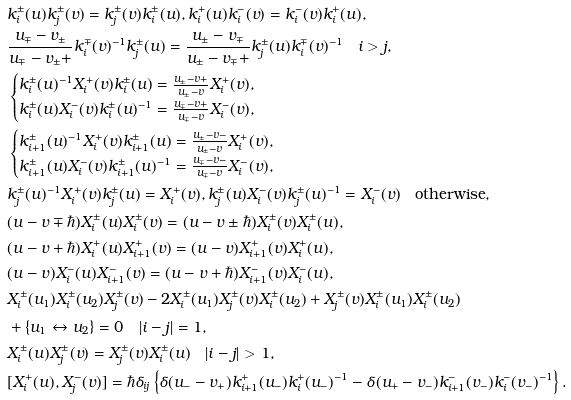Convert formula to latex. <formula><loc_0><loc_0><loc_500><loc_500>& k _ { i } ^ { \pm } ( u ) k _ { j } ^ { \pm } ( v ) = k _ { j } ^ { \pm } ( v ) k _ { i } ^ { \pm } ( u ) , k _ { i } ^ { + } ( u ) k _ { i } ^ { - } ( v ) = k _ { i } ^ { - } ( v ) k _ { i } ^ { + } ( u ) , \\ & \frac { u _ { \mp } - v _ { \pm } } { u _ { \mp } - v _ { \pm } + } k _ { i } ^ { \mp } ( v ) ^ { - 1 } k _ { j } ^ { \pm } ( u ) = \frac { u _ { \pm } - v _ { \mp } } { u _ { \pm } - v _ { \mp } + } k _ { j } ^ { \pm } ( u ) k _ { i } ^ { \mp } ( v ) ^ { - 1 } \quad i > j , \\ & \begin{cases} k _ { i } ^ { \pm } ( u ) ^ { - 1 } X _ { i } ^ { + } ( v ) k _ { i } ^ { \pm } ( u ) = \frac { u _ { \pm } - v + } { u _ { \pm } - v } X _ { i } ^ { + } ( v ) , & \\ k _ { i } ^ { \pm } ( u ) X _ { i } ^ { - } ( v ) k _ { i } ^ { \pm } ( u ) ^ { - 1 } = \frac { u _ { \mp } - v + } { u _ { \mp } - v } X _ { i } ^ { - } ( v ) , & \end{cases} \\ & \begin{cases} k _ { i + 1 } ^ { \pm } ( u ) ^ { - 1 } X _ { i } ^ { + } ( v ) k _ { i + 1 } ^ { \pm } ( u ) = \frac { u _ { \pm } - v - } { u _ { \pm } - v } X _ { i } ^ { + } ( v ) , & \\ k _ { i + 1 } ^ { \pm } ( u ) X _ { i } ^ { - } ( v ) k _ { i + 1 } ^ { \pm } ( u ) ^ { - 1 } = \frac { u _ { \mp } - v - } { u _ { \mp } - v } X _ { i } ^ { - } ( v ) , & \end{cases} \\ & k _ { j } ^ { \pm } ( u ) ^ { - 1 } X _ { i } ^ { + } ( v ) k _ { j } ^ { \pm } ( u ) = X _ { i } ^ { + } ( v ) , k _ { j } ^ { \pm } ( u ) X _ { i } ^ { - } ( v ) k _ { j } ^ { \pm } ( u ) ^ { - 1 } = X _ { i } ^ { - } ( v ) \quad \text {otherwise} , \\ & ( u - v \mp \hbar { ) } X _ { i } ^ { \pm } ( u ) X _ { i } ^ { \pm } ( v ) = ( u - v \pm \hbar { ) } X _ { i } ^ { \pm } ( v ) X _ { i } ^ { \pm } ( u ) , \\ & ( u - v + \hbar { ) } X _ { i } ^ { + } ( u ) X _ { i + 1 } ^ { + } ( v ) = ( u - v ) X _ { i + 1 } ^ { + } ( v ) X _ { i } ^ { + } ( u ) , \\ & ( u - v ) X _ { i } ^ { - } ( u ) X _ { i + 1 } ^ { - } ( v ) = ( u - v + \hbar { ) } X _ { i + 1 } ^ { - } ( v ) X _ { i } ^ { - } ( u ) , \\ & X _ { i } ^ { \pm } ( u _ { 1 } ) X _ { i } ^ { \pm } ( u _ { 2 } ) X _ { j } ^ { \pm } ( v ) - 2 X _ { i } ^ { \pm } ( u _ { 1 } ) X _ { j } ^ { \pm } ( v ) X _ { i } ^ { \pm } ( u _ { 2 } ) + X _ { j } ^ { \pm } ( v ) X _ { i } ^ { \pm } ( u _ { 1 } ) X _ { i } ^ { \pm } ( u _ { 2 } ) \\ & + \{ u _ { 1 } \leftrightarrow u _ { 2 } \} = 0 \quad | i - j | = 1 , \\ & X _ { i } ^ { \pm } ( u ) X _ { j } ^ { \pm } ( v ) = X _ { j } ^ { \pm } ( v ) X _ { i } ^ { \pm } ( u ) \quad | i - j | > 1 , \\ & [ X _ { i } ^ { + } ( u ) , X _ { j } ^ { - } ( v ) ] = \hbar { \delta } _ { i j } \left \{ \delta ( u _ { - } - v _ { + } ) k _ { i + 1 } ^ { + } ( u _ { - } ) k _ { i } ^ { + } ( u _ { - } ) ^ { - 1 } - \delta ( u _ { + } - v _ { - } ) k _ { i + 1 } ^ { - } ( v _ { - } ) k _ { i } ^ { - } ( v _ { - } ) ^ { - 1 } \right \} .</formula> 